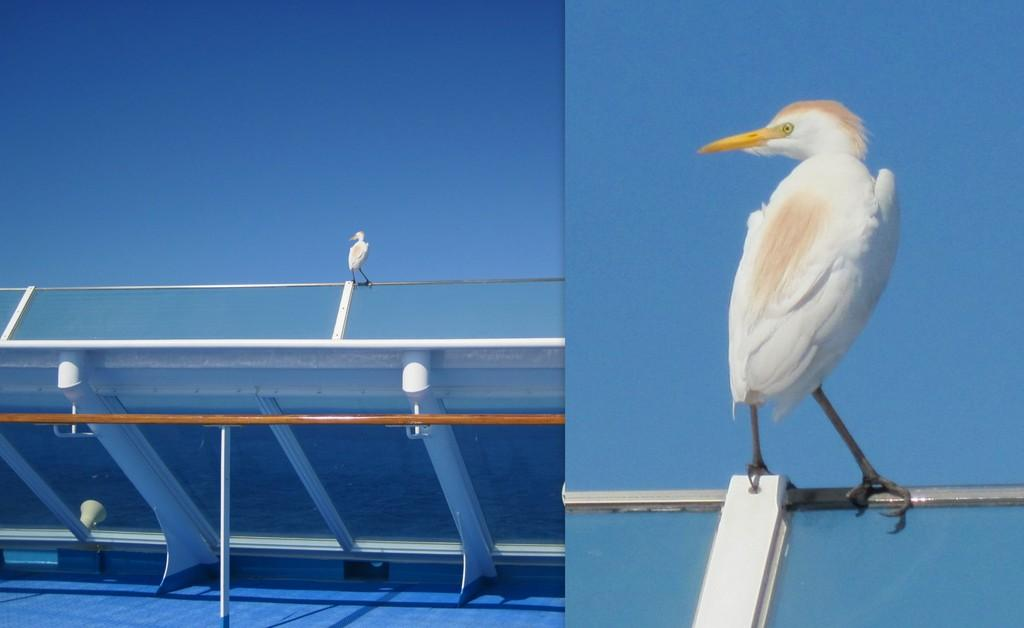What type of picture is in the image? There is a collage picture in the image. What can be seen on the railing in the image? There is a bird on the railing in the image. What colors does the bird have? The bird has white and cream color. What is the color of the sky in the background? The sky in the background is blue. What type of clam is sitting on the railing next to the bird in the image? There is no clam present in the image; it only features a bird on the railing. What type of wood can be seen in the image? There is no specific type of wood mentioned or visible in the image. 